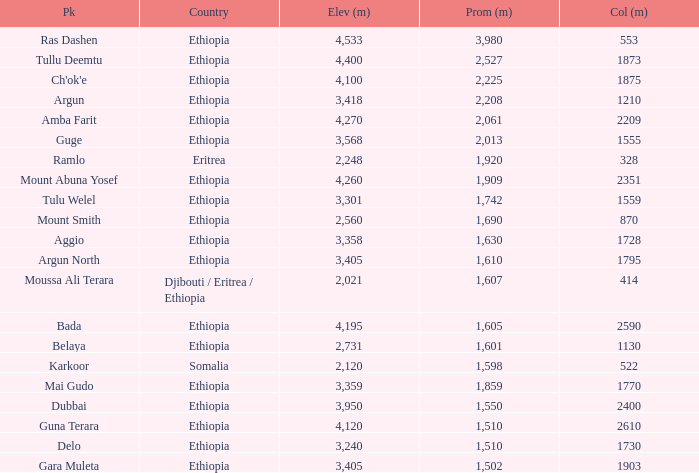What is the total prominence number in m of ethiopia, which has a col in m of 1728 and an elevation less than 3,358? 0.0. 